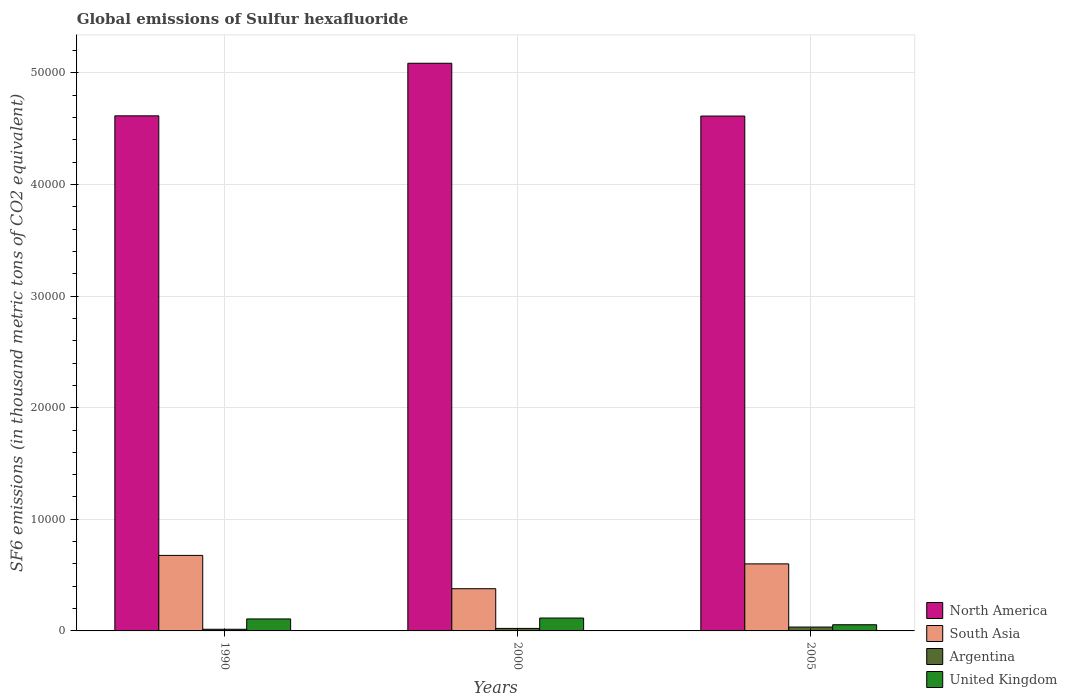Are the number of bars per tick equal to the number of legend labels?
Your answer should be compact. Yes. How many bars are there on the 3rd tick from the right?
Your answer should be very brief. 4. What is the global emissions of Sulfur hexafluoride in Argentina in 2000?
Ensure brevity in your answer.  224. Across all years, what is the maximum global emissions of Sulfur hexafluoride in United Kingdom?
Make the answer very short. 1154.1. Across all years, what is the minimum global emissions of Sulfur hexafluoride in Argentina?
Keep it short and to the point. 149.6. In which year was the global emissions of Sulfur hexafluoride in United Kingdom minimum?
Your response must be concise. 2005. What is the total global emissions of Sulfur hexafluoride in South Asia in the graph?
Ensure brevity in your answer.  1.66e+04. What is the difference between the global emissions of Sulfur hexafluoride in North America in 1990 and that in 2005?
Offer a terse response. 18.26. What is the difference between the global emissions of Sulfur hexafluoride in North America in 2000 and the global emissions of Sulfur hexafluoride in United Kingdom in 2005?
Your answer should be compact. 5.03e+04. What is the average global emissions of Sulfur hexafluoride in United Kingdom per year?
Offer a terse response. 927.4. In the year 1990, what is the difference between the global emissions of Sulfur hexafluoride in Argentina and global emissions of Sulfur hexafluoride in South Asia?
Give a very brief answer. -6616.9. What is the ratio of the global emissions of Sulfur hexafluoride in Argentina in 1990 to that in 2000?
Provide a short and direct response. 0.67. What is the difference between the highest and the second highest global emissions of Sulfur hexafluoride in South Asia?
Provide a short and direct response. 758.94. What is the difference between the highest and the lowest global emissions of Sulfur hexafluoride in North America?
Make the answer very short. 4729.16. Is the sum of the global emissions of Sulfur hexafluoride in North America in 1990 and 2005 greater than the maximum global emissions of Sulfur hexafluoride in United Kingdom across all years?
Your answer should be compact. Yes. Is it the case that in every year, the sum of the global emissions of Sulfur hexafluoride in United Kingdom and global emissions of Sulfur hexafluoride in North America is greater than the sum of global emissions of Sulfur hexafluoride in Argentina and global emissions of Sulfur hexafluoride in South Asia?
Your answer should be very brief. Yes. What does the 4th bar from the left in 1990 represents?
Your response must be concise. United Kingdom. What does the 3rd bar from the right in 2005 represents?
Provide a succinct answer. South Asia. How many bars are there?
Provide a short and direct response. 12. Are all the bars in the graph horizontal?
Make the answer very short. No. How many years are there in the graph?
Ensure brevity in your answer.  3. Are the values on the major ticks of Y-axis written in scientific E-notation?
Ensure brevity in your answer.  No. How many legend labels are there?
Provide a succinct answer. 4. What is the title of the graph?
Provide a short and direct response. Global emissions of Sulfur hexafluoride. Does "Austria" appear as one of the legend labels in the graph?
Your answer should be compact. No. What is the label or title of the X-axis?
Your answer should be very brief. Years. What is the label or title of the Y-axis?
Keep it short and to the point. SF6 emissions (in thousand metric tons of CO2 equivalent). What is the SF6 emissions (in thousand metric tons of CO2 equivalent) of North America in 1990?
Your response must be concise. 4.62e+04. What is the SF6 emissions (in thousand metric tons of CO2 equivalent) in South Asia in 1990?
Offer a very short reply. 6766.5. What is the SF6 emissions (in thousand metric tons of CO2 equivalent) of Argentina in 1990?
Offer a very short reply. 149.6. What is the SF6 emissions (in thousand metric tons of CO2 equivalent) in United Kingdom in 1990?
Offer a terse response. 1073.9. What is the SF6 emissions (in thousand metric tons of CO2 equivalent) of North America in 2000?
Keep it short and to the point. 5.09e+04. What is the SF6 emissions (in thousand metric tons of CO2 equivalent) of South Asia in 2000?
Provide a succinct answer. 3781.9. What is the SF6 emissions (in thousand metric tons of CO2 equivalent) in Argentina in 2000?
Your response must be concise. 224. What is the SF6 emissions (in thousand metric tons of CO2 equivalent) in United Kingdom in 2000?
Provide a succinct answer. 1154.1. What is the SF6 emissions (in thousand metric tons of CO2 equivalent) in North America in 2005?
Your response must be concise. 4.61e+04. What is the SF6 emissions (in thousand metric tons of CO2 equivalent) of South Asia in 2005?
Provide a short and direct response. 6007.56. What is the SF6 emissions (in thousand metric tons of CO2 equivalent) in Argentina in 2005?
Offer a terse response. 346.2. What is the SF6 emissions (in thousand metric tons of CO2 equivalent) of United Kingdom in 2005?
Your answer should be very brief. 554.2. Across all years, what is the maximum SF6 emissions (in thousand metric tons of CO2 equivalent) in North America?
Offer a terse response. 5.09e+04. Across all years, what is the maximum SF6 emissions (in thousand metric tons of CO2 equivalent) in South Asia?
Make the answer very short. 6766.5. Across all years, what is the maximum SF6 emissions (in thousand metric tons of CO2 equivalent) of Argentina?
Your answer should be very brief. 346.2. Across all years, what is the maximum SF6 emissions (in thousand metric tons of CO2 equivalent) in United Kingdom?
Make the answer very short. 1154.1. Across all years, what is the minimum SF6 emissions (in thousand metric tons of CO2 equivalent) in North America?
Give a very brief answer. 4.61e+04. Across all years, what is the minimum SF6 emissions (in thousand metric tons of CO2 equivalent) of South Asia?
Provide a short and direct response. 3781.9. Across all years, what is the minimum SF6 emissions (in thousand metric tons of CO2 equivalent) of Argentina?
Your answer should be compact. 149.6. Across all years, what is the minimum SF6 emissions (in thousand metric tons of CO2 equivalent) in United Kingdom?
Offer a very short reply. 554.2. What is the total SF6 emissions (in thousand metric tons of CO2 equivalent) of North America in the graph?
Your answer should be compact. 1.43e+05. What is the total SF6 emissions (in thousand metric tons of CO2 equivalent) in South Asia in the graph?
Make the answer very short. 1.66e+04. What is the total SF6 emissions (in thousand metric tons of CO2 equivalent) of Argentina in the graph?
Give a very brief answer. 719.8. What is the total SF6 emissions (in thousand metric tons of CO2 equivalent) in United Kingdom in the graph?
Make the answer very short. 2782.2. What is the difference between the SF6 emissions (in thousand metric tons of CO2 equivalent) of North America in 1990 and that in 2000?
Your response must be concise. -4710.9. What is the difference between the SF6 emissions (in thousand metric tons of CO2 equivalent) of South Asia in 1990 and that in 2000?
Provide a succinct answer. 2984.6. What is the difference between the SF6 emissions (in thousand metric tons of CO2 equivalent) in Argentina in 1990 and that in 2000?
Offer a terse response. -74.4. What is the difference between the SF6 emissions (in thousand metric tons of CO2 equivalent) in United Kingdom in 1990 and that in 2000?
Keep it short and to the point. -80.2. What is the difference between the SF6 emissions (in thousand metric tons of CO2 equivalent) of North America in 1990 and that in 2005?
Offer a very short reply. 18.26. What is the difference between the SF6 emissions (in thousand metric tons of CO2 equivalent) of South Asia in 1990 and that in 2005?
Your answer should be very brief. 758.94. What is the difference between the SF6 emissions (in thousand metric tons of CO2 equivalent) of Argentina in 1990 and that in 2005?
Ensure brevity in your answer.  -196.6. What is the difference between the SF6 emissions (in thousand metric tons of CO2 equivalent) of United Kingdom in 1990 and that in 2005?
Offer a very short reply. 519.7. What is the difference between the SF6 emissions (in thousand metric tons of CO2 equivalent) of North America in 2000 and that in 2005?
Your response must be concise. 4729.16. What is the difference between the SF6 emissions (in thousand metric tons of CO2 equivalent) of South Asia in 2000 and that in 2005?
Offer a terse response. -2225.66. What is the difference between the SF6 emissions (in thousand metric tons of CO2 equivalent) of Argentina in 2000 and that in 2005?
Offer a very short reply. -122.2. What is the difference between the SF6 emissions (in thousand metric tons of CO2 equivalent) in United Kingdom in 2000 and that in 2005?
Ensure brevity in your answer.  599.9. What is the difference between the SF6 emissions (in thousand metric tons of CO2 equivalent) of North America in 1990 and the SF6 emissions (in thousand metric tons of CO2 equivalent) of South Asia in 2000?
Your response must be concise. 4.24e+04. What is the difference between the SF6 emissions (in thousand metric tons of CO2 equivalent) of North America in 1990 and the SF6 emissions (in thousand metric tons of CO2 equivalent) of Argentina in 2000?
Offer a terse response. 4.59e+04. What is the difference between the SF6 emissions (in thousand metric tons of CO2 equivalent) of North America in 1990 and the SF6 emissions (in thousand metric tons of CO2 equivalent) of United Kingdom in 2000?
Keep it short and to the point. 4.50e+04. What is the difference between the SF6 emissions (in thousand metric tons of CO2 equivalent) in South Asia in 1990 and the SF6 emissions (in thousand metric tons of CO2 equivalent) in Argentina in 2000?
Keep it short and to the point. 6542.5. What is the difference between the SF6 emissions (in thousand metric tons of CO2 equivalent) in South Asia in 1990 and the SF6 emissions (in thousand metric tons of CO2 equivalent) in United Kingdom in 2000?
Offer a terse response. 5612.4. What is the difference between the SF6 emissions (in thousand metric tons of CO2 equivalent) in Argentina in 1990 and the SF6 emissions (in thousand metric tons of CO2 equivalent) in United Kingdom in 2000?
Keep it short and to the point. -1004.5. What is the difference between the SF6 emissions (in thousand metric tons of CO2 equivalent) of North America in 1990 and the SF6 emissions (in thousand metric tons of CO2 equivalent) of South Asia in 2005?
Provide a short and direct response. 4.01e+04. What is the difference between the SF6 emissions (in thousand metric tons of CO2 equivalent) of North America in 1990 and the SF6 emissions (in thousand metric tons of CO2 equivalent) of Argentina in 2005?
Provide a succinct answer. 4.58e+04. What is the difference between the SF6 emissions (in thousand metric tons of CO2 equivalent) in North America in 1990 and the SF6 emissions (in thousand metric tons of CO2 equivalent) in United Kingdom in 2005?
Your answer should be compact. 4.56e+04. What is the difference between the SF6 emissions (in thousand metric tons of CO2 equivalent) in South Asia in 1990 and the SF6 emissions (in thousand metric tons of CO2 equivalent) in Argentina in 2005?
Give a very brief answer. 6420.3. What is the difference between the SF6 emissions (in thousand metric tons of CO2 equivalent) of South Asia in 1990 and the SF6 emissions (in thousand metric tons of CO2 equivalent) of United Kingdom in 2005?
Offer a very short reply. 6212.3. What is the difference between the SF6 emissions (in thousand metric tons of CO2 equivalent) in Argentina in 1990 and the SF6 emissions (in thousand metric tons of CO2 equivalent) in United Kingdom in 2005?
Make the answer very short. -404.6. What is the difference between the SF6 emissions (in thousand metric tons of CO2 equivalent) in North America in 2000 and the SF6 emissions (in thousand metric tons of CO2 equivalent) in South Asia in 2005?
Provide a short and direct response. 4.49e+04. What is the difference between the SF6 emissions (in thousand metric tons of CO2 equivalent) of North America in 2000 and the SF6 emissions (in thousand metric tons of CO2 equivalent) of Argentina in 2005?
Provide a short and direct response. 5.05e+04. What is the difference between the SF6 emissions (in thousand metric tons of CO2 equivalent) of North America in 2000 and the SF6 emissions (in thousand metric tons of CO2 equivalent) of United Kingdom in 2005?
Your answer should be compact. 5.03e+04. What is the difference between the SF6 emissions (in thousand metric tons of CO2 equivalent) of South Asia in 2000 and the SF6 emissions (in thousand metric tons of CO2 equivalent) of Argentina in 2005?
Offer a very short reply. 3435.7. What is the difference between the SF6 emissions (in thousand metric tons of CO2 equivalent) of South Asia in 2000 and the SF6 emissions (in thousand metric tons of CO2 equivalent) of United Kingdom in 2005?
Give a very brief answer. 3227.7. What is the difference between the SF6 emissions (in thousand metric tons of CO2 equivalent) of Argentina in 2000 and the SF6 emissions (in thousand metric tons of CO2 equivalent) of United Kingdom in 2005?
Your response must be concise. -330.2. What is the average SF6 emissions (in thousand metric tons of CO2 equivalent) in North America per year?
Offer a terse response. 4.77e+04. What is the average SF6 emissions (in thousand metric tons of CO2 equivalent) of South Asia per year?
Offer a very short reply. 5518.65. What is the average SF6 emissions (in thousand metric tons of CO2 equivalent) in Argentina per year?
Your response must be concise. 239.93. What is the average SF6 emissions (in thousand metric tons of CO2 equivalent) of United Kingdom per year?
Make the answer very short. 927.4. In the year 1990, what is the difference between the SF6 emissions (in thousand metric tons of CO2 equivalent) in North America and SF6 emissions (in thousand metric tons of CO2 equivalent) in South Asia?
Your answer should be compact. 3.94e+04. In the year 1990, what is the difference between the SF6 emissions (in thousand metric tons of CO2 equivalent) of North America and SF6 emissions (in thousand metric tons of CO2 equivalent) of Argentina?
Keep it short and to the point. 4.60e+04. In the year 1990, what is the difference between the SF6 emissions (in thousand metric tons of CO2 equivalent) in North America and SF6 emissions (in thousand metric tons of CO2 equivalent) in United Kingdom?
Provide a succinct answer. 4.51e+04. In the year 1990, what is the difference between the SF6 emissions (in thousand metric tons of CO2 equivalent) of South Asia and SF6 emissions (in thousand metric tons of CO2 equivalent) of Argentina?
Make the answer very short. 6616.9. In the year 1990, what is the difference between the SF6 emissions (in thousand metric tons of CO2 equivalent) of South Asia and SF6 emissions (in thousand metric tons of CO2 equivalent) of United Kingdom?
Your answer should be very brief. 5692.6. In the year 1990, what is the difference between the SF6 emissions (in thousand metric tons of CO2 equivalent) in Argentina and SF6 emissions (in thousand metric tons of CO2 equivalent) in United Kingdom?
Keep it short and to the point. -924.3. In the year 2000, what is the difference between the SF6 emissions (in thousand metric tons of CO2 equivalent) in North America and SF6 emissions (in thousand metric tons of CO2 equivalent) in South Asia?
Offer a very short reply. 4.71e+04. In the year 2000, what is the difference between the SF6 emissions (in thousand metric tons of CO2 equivalent) of North America and SF6 emissions (in thousand metric tons of CO2 equivalent) of Argentina?
Offer a terse response. 5.06e+04. In the year 2000, what is the difference between the SF6 emissions (in thousand metric tons of CO2 equivalent) of North America and SF6 emissions (in thousand metric tons of CO2 equivalent) of United Kingdom?
Provide a short and direct response. 4.97e+04. In the year 2000, what is the difference between the SF6 emissions (in thousand metric tons of CO2 equivalent) in South Asia and SF6 emissions (in thousand metric tons of CO2 equivalent) in Argentina?
Your answer should be very brief. 3557.9. In the year 2000, what is the difference between the SF6 emissions (in thousand metric tons of CO2 equivalent) of South Asia and SF6 emissions (in thousand metric tons of CO2 equivalent) of United Kingdom?
Your answer should be compact. 2627.8. In the year 2000, what is the difference between the SF6 emissions (in thousand metric tons of CO2 equivalent) of Argentina and SF6 emissions (in thousand metric tons of CO2 equivalent) of United Kingdom?
Your response must be concise. -930.1. In the year 2005, what is the difference between the SF6 emissions (in thousand metric tons of CO2 equivalent) in North America and SF6 emissions (in thousand metric tons of CO2 equivalent) in South Asia?
Ensure brevity in your answer.  4.01e+04. In the year 2005, what is the difference between the SF6 emissions (in thousand metric tons of CO2 equivalent) in North America and SF6 emissions (in thousand metric tons of CO2 equivalent) in Argentina?
Offer a terse response. 4.58e+04. In the year 2005, what is the difference between the SF6 emissions (in thousand metric tons of CO2 equivalent) in North America and SF6 emissions (in thousand metric tons of CO2 equivalent) in United Kingdom?
Offer a very short reply. 4.56e+04. In the year 2005, what is the difference between the SF6 emissions (in thousand metric tons of CO2 equivalent) in South Asia and SF6 emissions (in thousand metric tons of CO2 equivalent) in Argentina?
Provide a short and direct response. 5661.36. In the year 2005, what is the difference between the SF6 emissions (in thousand metric tons of CO2 equivalent) in South Asia and SF6 emissions (in thousand metric tons of CO2 equivalent) in United Kingdom?
Make the answer very short. 5453.36. In the year 2005, what is the difference between the SF6 emissions (in thousand metric tons of CO2 equivalent) in Argentina and SF6 emissions (in thousand metric tons of CO2 equivalent) in United Kingdom?
Make the answer very short. -208. What is the ratio of the SF6 emissions (in thousand metric tons of CO2 equivalent) of North America in 1990 to that in 2000?
Offer a terse response. 0.91. What is the ratio of the SF6 emissions (in thousand metric tons of CO2 equivalent) of South Asia in 1990 to that in 2000?
Offer a very short reply. 1.79. What is the ratio of the SF6 emissions (in thousand metric tons of CO2 equivalent) of Argentina in 1990 to that in 2000?
Your response must be concise. 0.67. What is the ratio of the SF6 emissions (in thousand metric tons of CO2 equivalent) in United Kingdom in 1990 to that in 2000?
Offer a very short reply. 0.93. What is the ratio of the SF6 emissions (in thousand metric tons of CO2 equivalent) of South Asia in 1990 to that in 2005?
Give a very brief answer. 1.13. What is the ratio of the SF6 emissions (in thousand metric tons of CO2 equivalent) in Argentina in 1990 to that in 2005?
Ensure brevity in your answer.  0.43. What is the ratio of the SF6 emissions (in thousand metric tons of CO2 equivalent) in United Kingdom in 1990 to that in 2005?
Provide a short and direct response. 1.94. What is the ratio of the SF6 emissions (in thousand metric tons of CO2 equivalent) in North America in 2000 to that in 2005?
Ensure brevity in your answer.  1.1. What is the ratio of the SF6 emissions (in thousand metric tons of CO2 equivalent) of South Asia in 2000 to that in 2005?
Offer a terse response. 0.63. What is the ratio of the SF6 emissions (in thousand metric tons of CO2 equivalent) of Argentina in 2000 to that in 2005?
Make the answer very short. 0.65. What is the ratio of the SF6 emissions (in thousand metric tons of CO2 equivalent) of United Kingdom in 2000 to that in 2005?
Your answer should be compact. 2.08. What is the difference between the highest and the second highest SF6 emissions (in thousand metric tons of CO2 equivalent) in North America?
Offer a terse response. 4710.9. What is the difference between the highest and the second highest SF6 emissions (in thousand metric tons of CO2 equivalent) in South Asia?
Offer a terse response. 758.94. What is the difference between the highest and the second highest SF6 emissions (in thousand metric tons of CO2 equivalent) of Argentina?
Keep it short and to the point. 122.2. What is the difference between the highest and the second highest SF6 emissions (in thousand metric tons of CO2 equivalent) of United Kingdom?
Offer a terse response. 80.2. What is the difference between the highest and the lowest SF6 emissions (in thousand metric tons of CO2 equivalent) of North America?
Your answer should be very brief. 4729.16. What is the difference between the highest and the lowest SF6 emissions (in thousand metric tons of CO2 equivalent) in South Asia?
Ensure brevity in your answer.  2984.6. What is the difference between the highest and the lowest SF6 emissions (in thousand metric tons of CO2 equivalent) of Argentina?
Ensure brevity in your answer.  196.6. What is the difference between the highest and the lowest SF6 emissions (in thousand metric tons of CO2 equivalent) of United Kingdom?
Make the answer very short. 599.9. 